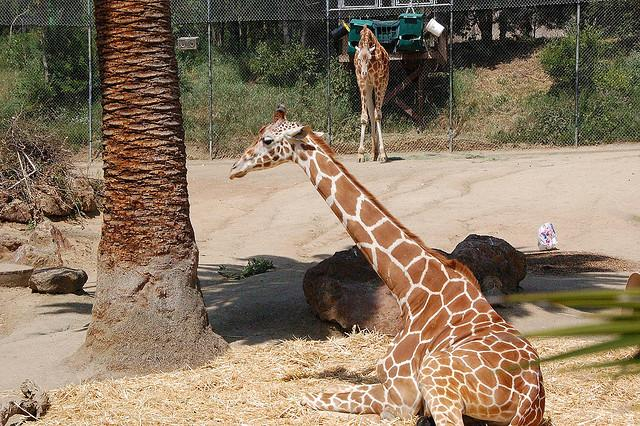What state of mind is the giraffe most likely in?

Choices:
A) angry
B) anxious
C) upset
D) relaxed relaxed 